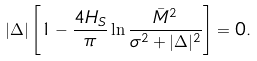Convert formula to latex. <formula><loc_0><loc_0><loc_500><loc_500>| \Delta | \left [ 1 - \frac { 4 H _ { S } } { \pi } \ln \frac { \bar { M } ^ { 2 } } { \sigma ^ { 2 } + | \Delta | ^ { 2 } } \right ] = 0 .</formula> 